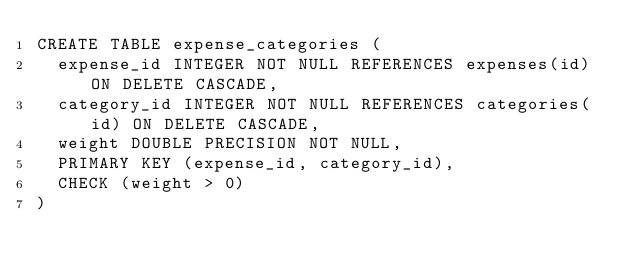Convert code to text. <code><loc_0><loc_0><loc_500><loc_500><_SQL_>CREATE TABLE expense_categories (
  expense_id INTEGER NOT NULL REFERENCES expenses(id) ON DELETE CASCADE,
  category_id INTEGER NOT NULL REFERENCES categories(id) ON DELETE CASCADE,
  weight DOUBLE PRECISION NOT NULL,
  PRIMARY KEY (expense_id, category_id),
  CHECK (weight > 0)
)
</code> 